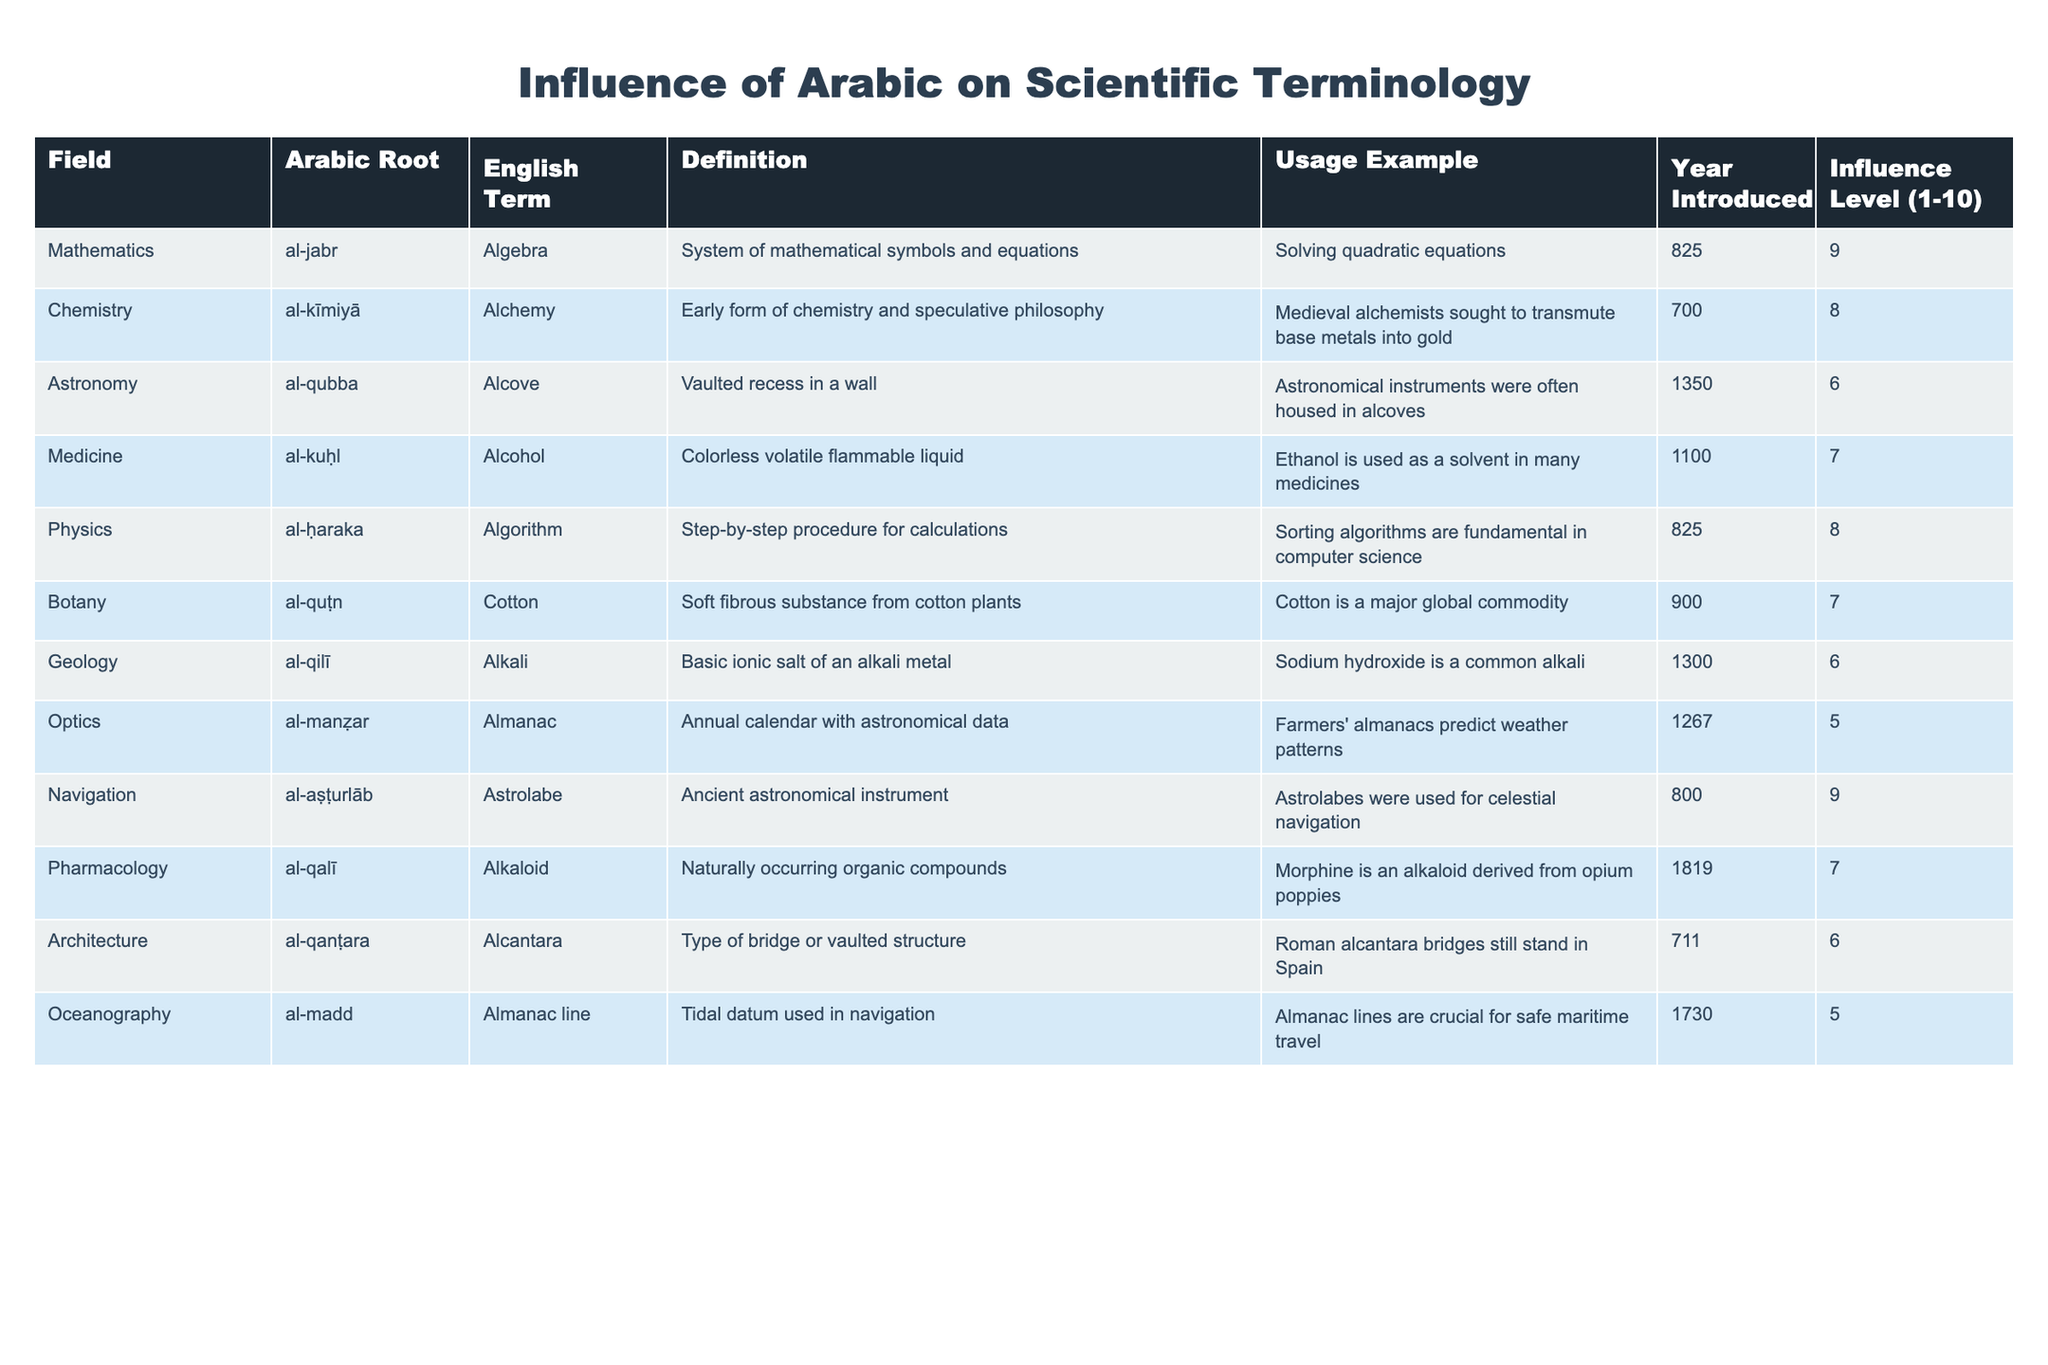What is the Arabic root for the term "Algorithm"? The table indicates that the Arabic root for "Algorithm" is "al-ḥaraka".
Answer: al-ḥaraka Which scientific field has the highest influence level according to the table? The table shows that "Mathematics" has the highest influence level of 9.
Answer: Mathematics In what year was the term "Alcohol" introduced? Referring to the table, "Alcohol" was introduced in the year 1100.
Answer: 1100 True or False: The term "Alchemy" has an influence level greater than 6. According to the table, "Alchemy" has an influence level of 8, which is greater than 6, making the statement true.
Answer: True What is the average influence level of the fields listed in the table? First, we find the sum of the influence levels: 9 + 8 + 6 + 7 + 8 + 7 + 6 + 5 + 7 + 6 + 5 = 66. There are 11 fields, so the average is 66/11 = 6. The average influence level is approximately 6.
Answer: 6 Which field uses the Arabic term "al-quṭn"? The table indicates that the Arabic term "al-quṭn" is used in the field of Botany.
Answer: Botany List all terms with an influence level of 5. The table shows the terms "Almanac" and "Almanac line" both have an influence level of 5.
Answer: Almanac, Almanac line What is the difference between the highest and lowest influence levels in the table? The highest influence level is 9 (Mathematics) and the lowest is 5 (Optics and Oceanography). The difference is 9 - 5 = 4.
Answer: 4 Is there a field in the table that has a term related to navigation? The table lists "Astrolabe" under the field of Navigation, confirming that there is indeed a relevant term.
Answer: Yes How many terms have an influence level greater than or equal to 7? The terms with influence levels of 7 or higher are: Algebra, Alchemy, Alcohol, Algorithm, Cotton, and Alkaloid, totaling 6 terms.
Answer: 6 